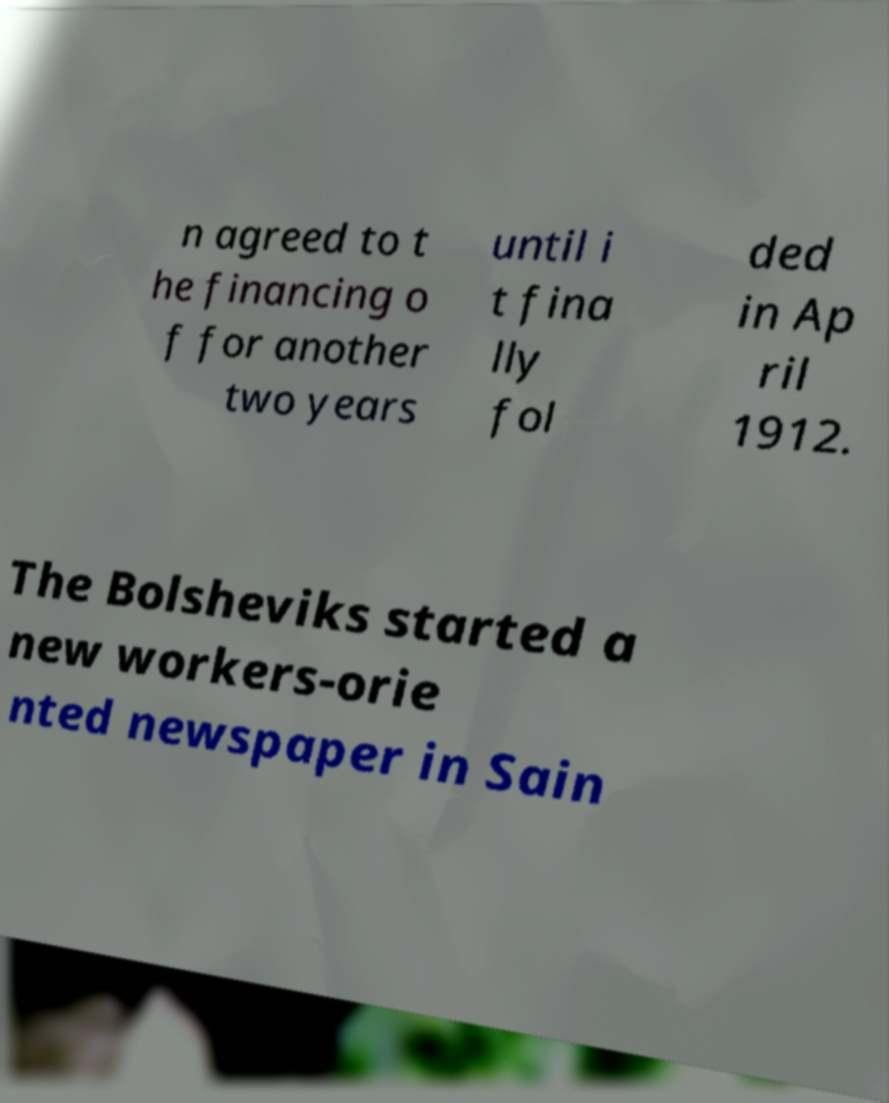For documentation purposes, I need the text within this image transcribed. Could you provide that? n agreed to t he financing o f for another two years until i t fina lly fol ded in Ap ril 1912. The Bolsheviks started a new workers-orie nted newspaper in Sain 